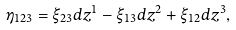<formula> <loc_0><loc_0><loc_500><loc_500>\eta _ { 1 2 3 } = \xi _ { 2 3 } d z ^ { 1 } - \xi _ { 1 3 } d z ^ { 2 } + \xi _ { 1 2 } d z ^ { 3 } ,</formula> 